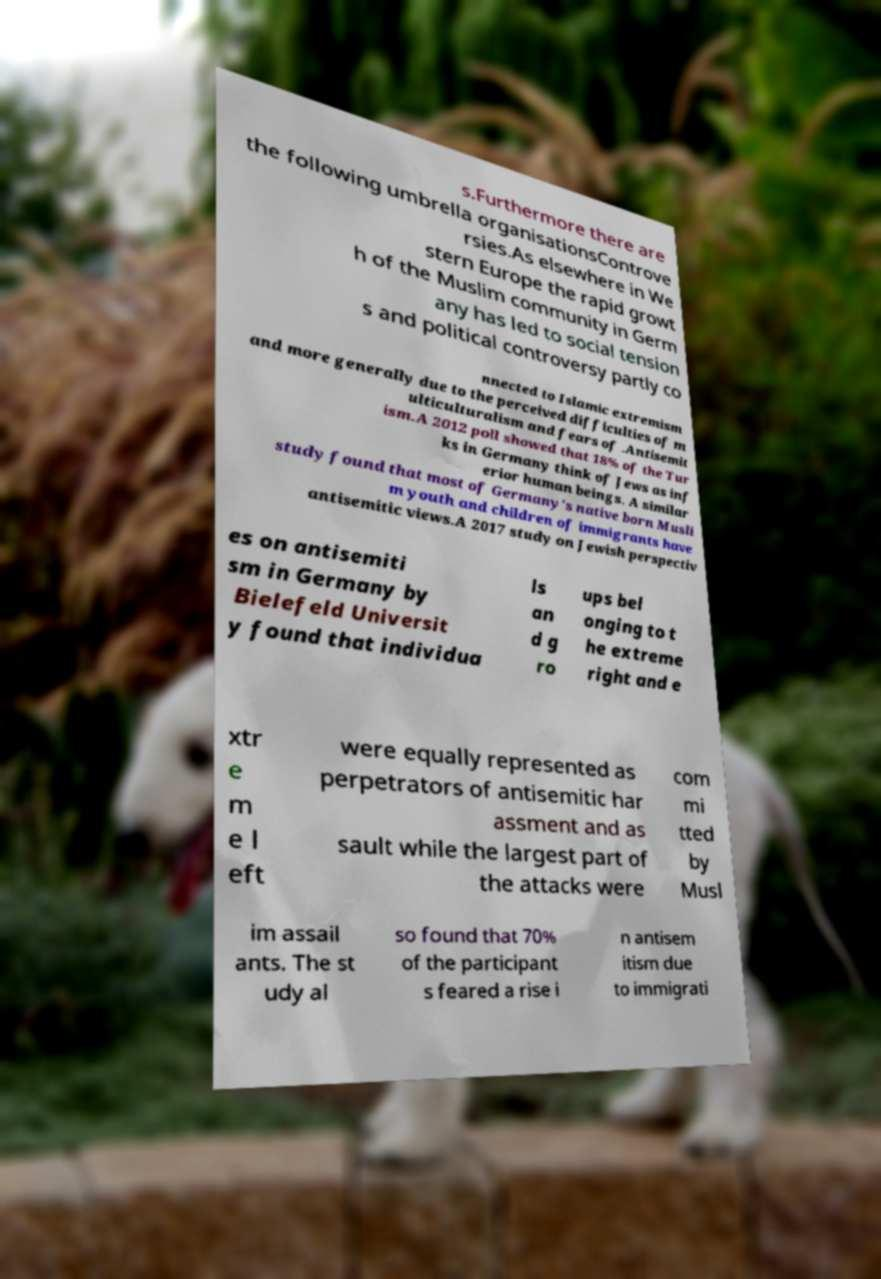Could you assist in decoding the text presented in this image and type it out clearly? s.Furthermore there are the following umbrella organisationsControve rsies.As elsewhere in We stern Europe the rapid growt h of the Muslim community in Germ any has led to social tension s and political controversy partly co nnected to Islamic extremism and more generally due to the perceived difficulties of m ulticulturalism and fears of .Antisemit ism.A 2012 poll showed that 18% of the Tur ks in Germany think of Jews as inf erior human beings. A similar study found that most of Germany's native born Musli m youth and children of immigrants have antisemitic views.A 2017 study on Jewish perspectiv es on antisemiti sm in Germany by Bielefeld Universit y found that individua ls an d g ro ups bel onging to t he extreme right and e xtr e m e l eft were equally represented as perpetrators of antisemitic har assment and as sault while the largest part of the attacks were com mi tted by Musl im assail ants. The st udy al so found that 70% of the participant s feared a rise i n antisem itism due to immigrati 